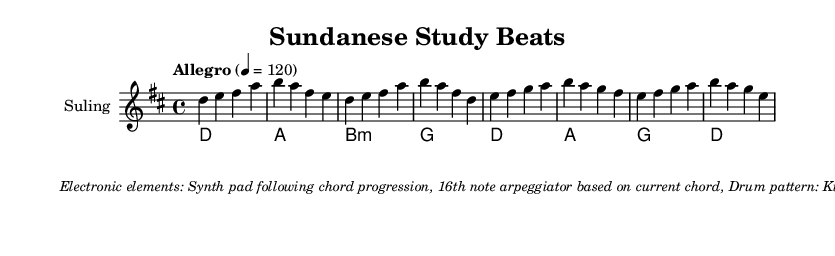What is the key signature of this music? The key signature indicated in the global settings shows two sharps, which corresponds to the D major scale.
Answer: D major What is the time signature of this piece? The time signature is shown in the global settings as 4/4, which indicates four beats per measure.
Answer: 4/4 What is the tempo marking of this music? The tempo marking specifies "Allegro" and indicates a speed of 120 beats per minute, which is quite fast.
Answer: Allegro, 120 How many measures does the suling melody have? By counting the segments in the suling part, there are a total of 8 measures present in the music score.
Answer: 8 What chord is played after the D major in the chord progression? The chord progression shown reveals that the chord following D major is A major.
Answer: A major What electronic elements are used in the music? The markup section enumerates the electronic elements including a synth pad, an arpeggiator, and a specific drum pattern which are vital for the fusion style.
Answer: Synth pad, 16th note arpeggiator, drum pattern What style of music is this score classified as? The title and musical elements, including the use of electronic components blended with traditional Sundanese instruments, categorize this score as a fusion style.
Answer: Fusion 